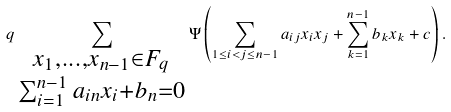<formula> <loc_0><loc_0><loc_500><loc_500>q \sum _ { \substack { x _ { 1 } , \dots , x _ { n - 1 } \in { F } _ { q } \\ \sum _ { i = 1 } ^ { n - 1 } a _ { i n } x _ { i } + b _ { n } = 0 } } \Psi \left ( \sum _ { 1 \leq i < j \leq n - 1 } a _ { i j } x _ { i } x _ { j } + \sum _ { k = 1 } ^ { n - 1 } b _ { k } x _ { k } + c \right ) .</formula> 